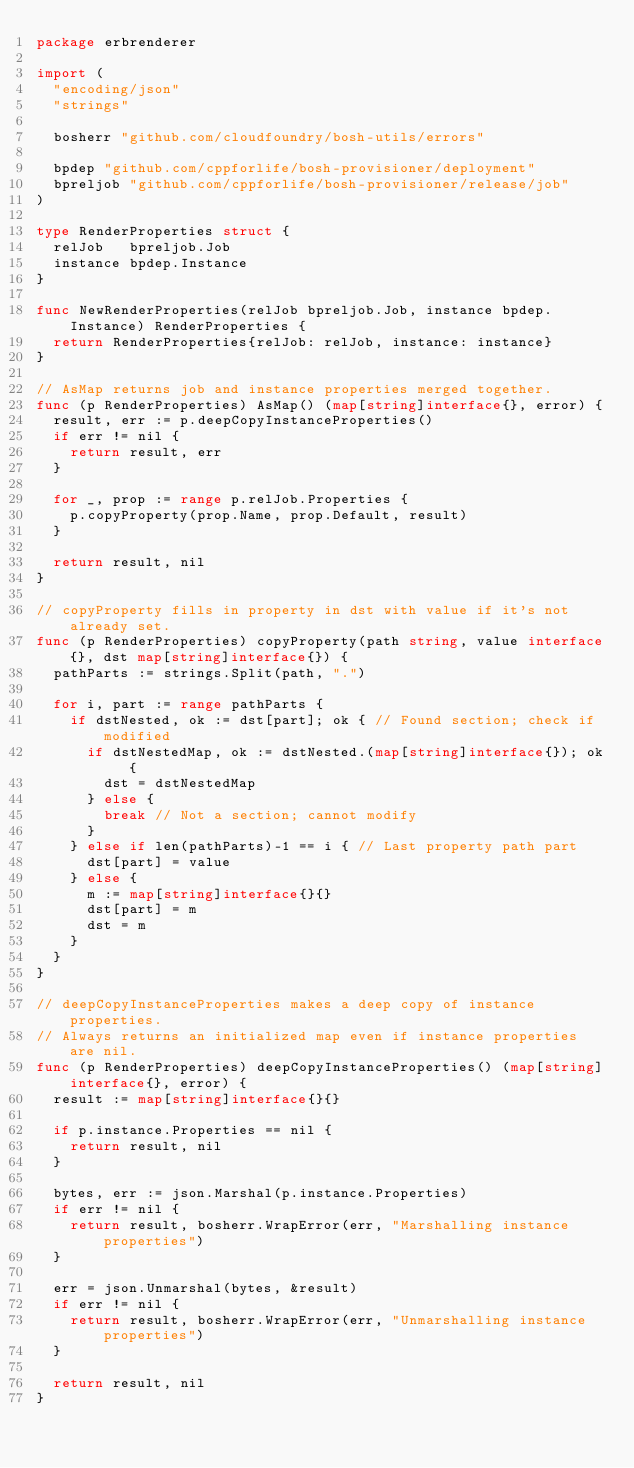<code> <loc_0><loc_0><loc_500><loc_500><_Go_>package erbrenderer

import (
	"encoding/json"
	"strings"

	bosherr "github.com/cloudfoundry/bosh-utils/errors"

	bpdep "github.com/cppforlife/bosh-provisioner/deployment"
	bpreljob "github.com/cppforlife/bosh-provisioner/release/job"
)

type RenderProperties struct {
	relJob   bpreljob.Job
	instance bpdep.Instance
}

func NewRenderProperties(relJob bpreljob.Job, instance bpdep.Instance) RenderProperties {
	return RenderProperties{relJob: relJob, instance: instance}
}

// AsMap returns job and instance properties merged together.
func (p RenderProperties) AsMap() (map[string]interface{}, error) {
	result, err := p.deepCopyInstanceProperties()
	if err != nil {
		return result, err
	}

	for _, prop := range p.relJob.Properties {
		p.copyProperty(prop.Name, prop.Default, result)
	}

	return result, nil
}

// copyProperty fills in property in dst with value if it's not already set.
func (p RenderProperties) copyProperty(path string, value interface{}, dst map[string]interface{}) {
	pathParts := strings.Split(path, ".")

	for i, part := range pathParts {
		if dstNested, ok := dst[part]; ok { // Found section; check if modified
			if dstNestedMap, ok := dstNested.(map[string]interface{}); ok {
				dst = dstNestedMap
			} else {
				break // Not a section; cannot modify
			}
		} else if len(pathParts)-1 == i { // Last property path part
			dst[part] = value
		} else {
			m := map[string]interface{}{}
			dst[part] = m
			dst = m
		}
	}
}

// deepCopyInstanceProperties makes a deep copy of instance properties.
// Always returns an initialized map even if instance properties are nil.
func (p RenderProperties) deepCopyInstanceProperties() (map[string]interface{}, error) {
	result := map[string]interface{}{}

	if p.instance.Properties == nil {
		return result, nil
	}

	bytes, err := json.Marshal(p.instance.Properties)
	if err != nil {
		return result, bosherr.WrapError(err, "Marshalling instance properties")
	}

	err = json.Unmarshal(bytes, &result)
	if err != nil {
		return result, bosherr.WrapError(err, "Unmarshalling instance properties")
	}

	return result, nil
}
</code> 